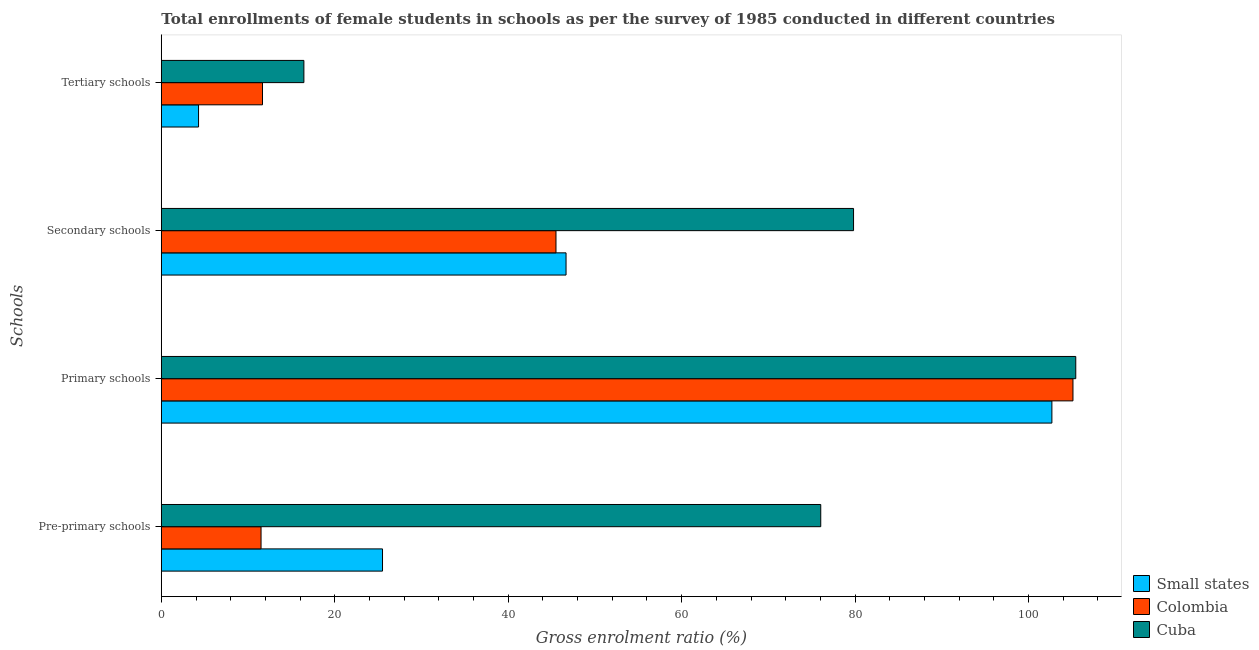Are the number of bars per tick equal to the number of legend labels?
Offer a very short reply. Yes. Are the number of bars on each tick of the Y-axis equal?
Keep it short and to the point. Yes. How many bars are there on the 1st tick from the bottom?
Offer a very short reply. 3. What is the label of the 1st group of bars from the top?
Your response must be concise. Tertiary schools. What is the gross enrolment ratio(female) in tertiary schools in Cuba?
Your response must be concise. 16.44. Across all countries, what is the maximum gross enrolment ratio(female) in tertiary schools?
Your response must be concise. 16.44. Across all countries, what is the minimum gross enrolment ratio(female) in pre-primary schools?
Your answer should be compact. 11.5. In which country was the gross enrolment ratio(female) in tertiary schools maximum?
Ensure brevity in your answer.  Cuba. In which country was the gross enrolment ratio(female) in pre-primary schools minimum?
Provide a short and direct response. Colombia. What is the total gross enrolment ratio(female) in primary schools in the graph?
Make the answer very short. 313.27. What is the difference between the gross enrolment ratio(female) in tertiary schools in Colombia and that in Cuba?
Offer a terse response. -4.77. What is the difference between the gross enrolment ratio(female) in tertiary schools in Cuba and the gross enrolment ratio(female) in primary schools in Small states?
Offer a terse response. -86.26. What is the average gross enrolment ratio(female) in secondary schools per country?
Ensure brevity in your answer.  57.34. What is the difference between the gross enrolment ratio(female) in primary schools and gross enrolment ratio(female) in tertiary schools in Colombia?
Provide a succinct answer. 93.46. In how many countries, is the gross enrolment ratio(female) in pre-primary schools greater than 16 %?
Offer a terse response. 2. What is the ratio of the gross enrolment ratio(female) in pre-primary schools in Colombia to that in Small states?
Make the answer very short. 0.45. Is the gross enrolment ratio(female) in secondary schools in Small states less than that in Colombia?
Keep it short and to the point. No. Is the difference between the gross enrolment ratio(female) in secondary schools in Cuba and Small states greater than the difference between the gross enrolment ratio(female) in primary schools in Cuba and Small states?
Offer a very short reply. Yes. What is the difference between the highest and the second highest gross enrolment ratio(female) in pre-primary schools?
Make the answer very short. 50.54. What is the difference between the highest and the lowest gross enrolment ratio(female) in secondary schools?
Offer a very short reply. 34.31. In how many countries, is the gross enrolment ratio(female) in secondary schools greater than the average gross enrolment ratio(female) in secondary schools taken over all countries?
Keep it short and to the point. 1. Is the sum of the gross enrolment ratio(female) in pre-primary schools in Cuba and Colombia greater than the maximum gross enrolment ratio(female) in primary schools across all countries?
Ensure brevity in your answer.  No. Is it the case that in every country, the sum of the gross enrolment ratio(female) in tertiary schools and gross enrolment ratio(female) in primary schools is greater than the sum of gross enrolment ratio(female) in secondary schools and gross enrolment ratio(female) in pre-primary schools?
Keep it short and to the point. No. What does the 1st bar from the bottom in Secondary schools represents?
Ensure brevity in your answer.  Small states. How many bars are there?
Provide a succinct answer. 12. Are the values on the major ticks of X-axis written in scientific E-notation?
Ensure brevity in your answer.  No. Does the graph contain grids?
Your answer should be very brief. No. Where does the legend appear in the graph?
Give a very brief answer. Bottom right. What is the title of the graph?
Ensure brevity in your answer.  Total enrollments of female students in schools as per the survey of 1985 conducted in different countries. Does "Montenegro" appear as one of the legend labels in the graph?
Give a very brief answer. No. What is the label or title of the Y-axis?
Keep it short and to the point. Schools. What is the Gross enrolment ratio (%) in Small states in Pre-primary schools?
Make the answer very short. 25.51. What is the Gross enrolment ratio (%) in Colombia in Pre-primary schools?
Offer a very short reply. 11.5. What is the Gross enrolment ratio (%) in Cuba in Pre-primary schools?
Your response must be concise. 76.04. What is the Gross enrolment ratio (%) of Small states in Primary schools?
Provide a short and direct response. 102.7. What is the Gross enrolment ratio (%) of Colombia in Primary schools?
Your response must be concise. 105.13. What is the Gross enrolment ratio (%) of Cuba in Primary schools?
Offer a very short reply. 105.45. What is the Gross enrolment ratio (%) of Small states in Secondary schools?
Ensure brevity in your answer.  46.67. What is the Gross enrolment ratio (%) in Colombia in Secondary schools?
Your answer should be very brief. 45.51. What is the Gross enrolment ratio (%) in Cuba in Secondary schools?
Provide a succinct answer. 79.82. What is the Gross enrolment ratio (%) of Small states in Tertiary schools?
Make the answer very short. 4.29. What is the Gross enrolment ratio (%) in Colombia in Tertiary schools?
Your answer should be very brief. 11.67. What is the Gross enrolment ratio (%) of Cuba in Tertiary schools?
Offer a terse response. 16.44. Across all Schools, what is the maximum Gross enrolment ratio (%) of Small states?
Your answer should be compact. 102.7. Across all Schools, what is the maximum Gross enrolment ratio (%) of Colombia?
Provide a short and direct response. 105.13. Across all Schools, what is the maximum Gross enrolment ratio (%) of Cuba?
Make the answer very short. 105.45. Across all Schools, what is the minimum Gross enrolment ratio (%) in Small states?
Keep it short and to the point. 4.29. Across all Schools, what is the minimum Gross enrolment ratio (%) of Colombia?
Give a very brief answer. 11.5. Across all Schools, what is the minimum Gross enrolment ratio (%) of Cuba?
Give a very brief answer. 16.44. What is the total Gross enrolment ratio (%) in Small states in the graph?
Keep it short and to the point. 179.17. What is the total Gross enrolment ratio (%) of Colombia in the graph?
Your response must be concise. 173.81. What is the total Gross enrolment ratio (%) of Cuba in the graph?
Your answer should be very brief. 277.76. What is the difference between the Gross enrolment ratio (%) of Small states in Pre-primary schools and that in Primary schools?
Give a very brief answer. -77.19. What is the difference between the Gross enrolment ratio (%) of Colombia in Pre-primary schools and that in Primary schools?
Your response must be concise. -93.63. What is the difference between the Gross enrolment ratio (%) in Cuba in Pre-primary schools and that in Primary schools?
Provide a succinct answer. -29.41. What is the difference between the Gross enrolment ratio (%) in Small states in Pre-primary schools and that in Secondary schools?
Give a very brief answer. -21.16. What is the difference between the Gross enrolment ratio (%) of Colombia in Pre-primary schools and that in Secondary schools?
Your response must be concise. -34.01. What is the difference between the Gross enrolment ratio (%) in Cuba in Pre-primary schools and that in Secondary schools?
Give a very brief answer. -3.78. What is the difference between the Gross enrolment ratio (%) of Small states in Pre-primary schools and that in Tertiary schools?
Your answer should be compact. 21.22. What is the difference between the Gross enrolment ratio (%) in Colombia in Pre-primary schools and that in Tertiary schools?
Ensure brevity in your answer.  -0.17. What is the difference between the Gross enrolment ratio (%) in Cuba in Pre-primary schools and that in Tertiary schools?
Ensure brevity in your answer.  59.6. What is the difference between the Gross enrolment ratio (%) in Small states in Primary schools and that in Secondary schools?
Your response must be concise. 56.02. What is the difference between the Gross enrolment ratio (%) in Colombia in Primary schools and that in Secondary schools?
Provide a short and direct response. 59.62. What is the difference between the Gross enrolment ratio (%) of Cuba in Primary schools and that in Secondary schools?
Keep it short and to the point. 25.63. What is the difference between the Gross enrolment ratio (%) in Small states in Primary schools and that in Tertiary schools?
Give a very brief answer. 98.4. What is the difference between the Gross enrolment ratio (%) in Colombia in Primary schools and that in Tertiary schools?
Your answer should be compact. 93.46. What is the difference between the Gross enrolment ratio (%) in Cuba in Primary schools and that in Tertiary schools?
Keep it short and to the point. 89.01. What is the difference between the Gross enrolment ratio (%) of Small states in Secondary schools and that in Tertiary schools?
Your answer should be compact. 42.38. What is the difference between the Gross enrolment ratio (%) of Colombia in Secondary schools and that in Tertiary schools?
Your response must be concise. 33.84. What is the difference between the Gross enrolment ratio (%) of Cuba in Secondary schools and that in Tertiary schools?
Offer a terse response. 63.38. What is the difference between the Gross enrolment ratio (%) of Small states in Pre-primary schools and the Gross enrolment ratio (%) of Colombia in Primary schools?
Provide a succinct answer. -79.62. What is the difference between the Gross enrolment ratio (%) of Small states in Pre-primary schools and the Gross enrolment ratio (%) of Cuba in Primary schools?
Provide a succinct answer. -79.94. What is the difference between the Gross enrolment ratio (%) in Colombia in Pre-primary schools and the Gross enrolment ratio (%) in Cuba in Primary schools?
Give a very brief answer. -93.95. What is the difference between the Gross enrolment ratio (%) in Small states in Pre-primary schools and the Gross enrolment ratio (%) in Colombia in Secondary schools?
Your answer should be very brief. -20. What is the difference between the Gross enrolment ratio (%) in Small states in Pre-primary schools and the Gross enrolment ratio (%) in Cuba in Secondary schools?
Your answer should be compact. -54.32. What is the difference between the Gross enrolment ratio (%) in Colombia in Pre-primary schools and the Gross enrolment ratio (%) in Cuba in Secondary schools?
Provide a succinct answer. -68.32. What is the difference between the Gross enrolment ratio (%) of Small states in Pre-primary schools and the Gross enrolment ratio (%) of Colombia in Tertiary schools?
Offer a very short reply. 13.84. What is the difference between the Gross enrolment ratio (%) in Small states in Pre-primary schools and the Gross enrolment ratio (%) in Cuba in Tertiary schools?
Make the answer very short. 9.07. What is the difference between the Gross enrolment ratio (%) in Colombia in Pre-primary schools and the Gross enrolment ratio (%) in Cuba in Tertiary schools?
Make the answer very short. -4.94. What is the difference between the Gross enrolment ratio (%) of Small states in Primary schools and the Gross enrolment ratio (%) of Colombia in Secondary schools?
Your response must be concise. 57.18. What is the difference between the Gross enrolment ratio (%) in Small states in Primary schools and the Gross enrolment ratio (%) in Cuba in Secondary schools?
Offer a very short reply. 22.87. What is the difference between the Gross enrolment ratio (%) in Colombia in Primary schools and the Gross enrolment ratio (%) in Cuba in Secondary schools?
Keep it short and to the point. 25.3. What is the difference between the Gross enrolment ratio (%) of Small states in Primary schools and the Gross enrolment ratio (%) of Colombia in Tertiary schools?
Give a very brief answer. 91.03. What is the difference between the Gross enrolment ratio (%) of Small states in Primary schools and the Gross enrolment ratio (%) of Cuba in Tertiary schools?
Ensure brevity in your answer.  86.26. What is the difference between the Gross enrolment ratio (%) of Colombia in Primary schools and the Gross enrolment ratio (%) of Cuba in Tertiary schools?
Your response must be concise. 88.69. What is the difference between the Gross enrolment ratio (%) in Small states in Secondary schools and the Gross enrolment ratio (%) in Colombia in Tertiary schools?
Your response must be concise. 35. What is the difference between the Gross enrolment ratio (%) of Small states in Secondary schools and the Gross enrolment ratio (%) of Cuba in Tertiary schools?
Offer a very short reply. 30.23. What is the difference between the Gross enrolment ratio (%) of Colombia in Secondary schools and the Gross enrolment ratio (%) of Cuba in Tertiary schools?
Your answer should be very brief. 29.07. What is the average Gross enrolment ratio (%) of Small states per Schools?
Your response must be concise. 44.79. What is the average Gross enrolment ratio (%) of Colombia per Schools?
Provide a short and direct response. 43.45. What is the average Gross enrolment ratio (%) of Cuba per Schools?
Make the answer very short. 69.44. What is the difference between the Gross enrolment ratio (%) of Small states and Gross enrolment ratio (%) of Colombia in Pre-primary schools?
Provide a short and direct response. 14.01. What is the difference between the Gross enrolment ratio (%) of Small states and Gross enrolment ratio (%) of Cuba in Pre-primary schools?
Make the answer very short. -50.54. What is the difference between the Gross enrolment ratio (%) of Colombia and Gross enrolment ratio (%) of Cuba in Pre-primary schools?
Offer a very short reply. -64.54. What is the difference between the Gross enrolment ratio (%) in Small states and Gross enrolment ratio (%) in Colombia in Primary schools?
Provide a succinct answer. -2.43. What is the difference between the Gross enrolment ratio (%) of Small states and Gross enrolment ratio (%) of Cuba in Primary schools?
Give a very brief answer. -2.75. What is the difference between the Gross enrolment ratio (%) of Colombia and Gross enrolment ratio (%) of Cuba in Primary schools?
Provide a succinct answer. -0.32. What is the difference between the Gross enrolment ratio (%) of Small states and Gross enrolment ratio (%) of Colombia in Secondary schools?
Give a very brief answer. 1.16. What is the difference between the Gross enrolment ratio (%) of Small states and Gross enrolment ratio (%) of Cuba in Secondary schools?
Your response must be concise. -33.15. What is the difference between the Gross enrolment ratio (%) in Colombia and Gross enrolment ratio (%) in Cuba in Secondary schools?
Provide a short and direct response. -34.31. What is the difference between the Gross enrolment ratio (%) in Small states and Gross enrolment ratio (%) in Colombia in Tertiary schools?
Ensure brevity in your answer.  -7.38. What is the difference between the Gross enrolment ratio (%) of Small states and Gross enrolment ratio (%) of Cuba in Tertiary schools?
Make the answer very short. -12.15. What is the difference between the Gross enrolment ratio (%) in Colombia and Gross enrolment ratio (%) in Cuba in Tertiary schools?
Your response must be concise. -4.77. What is the ratio of the Gross enrolment ratio (%) of Small states in Pre-primary schools to that in Primary schools?
Give a very brief answer. 0.25. What is the ratio of the Gross enrolment ratio (%) in Colombia in Pre-primary schools to that in Primary schools?
Keep it short and to the point. 0.11. What is the ratio of the Gross enrolment ratio (%) in Cuba in Pre-primary schools to that in Primary schools?
Ensure brevity in your answer.  0.72. What is the ratio of the Gross enrolment ratio (%) of Small states in Pre-primary schools to that in Secondary schools?
Provide a short and direct response. 0.55. What is the ratio of the Gross enrolment ratio (%) in Colombia in Pre-primary schools to that in Secondary schools?
Offer a terse response. 0.25. What is the ratio of the Gross enrolment ratio (%) of Cuba in Pre-primary schools to that in Secondary schools?
Ensure brevity in your answer.  0.95. What is the ratio of the Gross enrolment ratio (%) in Small states in Pre-primary schools to that in Tertiary schools?
Provide a short and direct response. 5.94. What is the ratio of the Gross enrolment ratio (%) in Colombia in Pre-primary schools to that in Tertiary schools?
Give a very brief answer. 0.99. What is the ratio of the Gross enrolment ratio (%) in Cuba in Pre-primary schools to that in Tertiary schools?
Provide a short and direct response. 4.63. What is the ratio of the Gross enrolment ratio (%) in Small states in Primary schools to that in Secondary schools?
Provide a succinct answer. 2.2. What is the ratio of the Gross enrolment ratio (%) in Colombia in Primary schools to that in Secondary schools?
Provide a succinct answer. 2.31. What is the ratio of the Gross enrolment ratio (%) in Cuba in Primary schools to that in Secondary schools?
Ensure brevity in your answer.  1.32. What is the ratio of the Gross enrolment ratio (%) in Small states in Primary schools to that in Tertiary schools?
Your answer should be compact. 23.93. What is the ratio of the Gross enrolment ratio (%) in Colombia in Primary schools to that in Tertiary schools?
Keep it short and to the point. 9.01. What is the ratio of the Gross enrolment ratio (%) in Cuba in Primary schools to that in Tertiary schools?
Give a very brief answer. 6.41. What is the ratio of the Gross enrolment ratio (%) of Small states in Secondary schools to that in Tertiary schools?
Your response must be concise. 10.87. What is the ratio of the Gross enrolment ratio (%) of Colombia in Secondary schools to that in Tertiary schools?
Offer a very short reply. 3.9. What is the ratio of the Gross enrolment ratio (%) in Cuba in Secondary schools to that in Tertiary schools?
Provide a short and direct response. 4.86. What is the difference between the highest and the second highest Gross enrolment ratio (%) of Small states?
Your answer should be compact. 56.02. What is the difference between the highest and the second highest Gross enrolment ratio (%) of Colombia?
Provide a short and direct response. 59.62. What is the difference between the highest and the second highest Gross enrolment ratio (%) of Cuba?
Your answer should be very brief. 25.63. What is the difference between the highest and the lowest Gross enrolment ratio (%) of Small states?
Offer a very short reply. 98.4. What is the difference between the highest and the lowest Gross enrolment ratio (%) of Colombia?
Your answer should be very brief. 93.63. What is the difference between the highest and the lowest Gross enrolment ratio (%) of Cuba?
Provide a succinct answer. 89.01. 